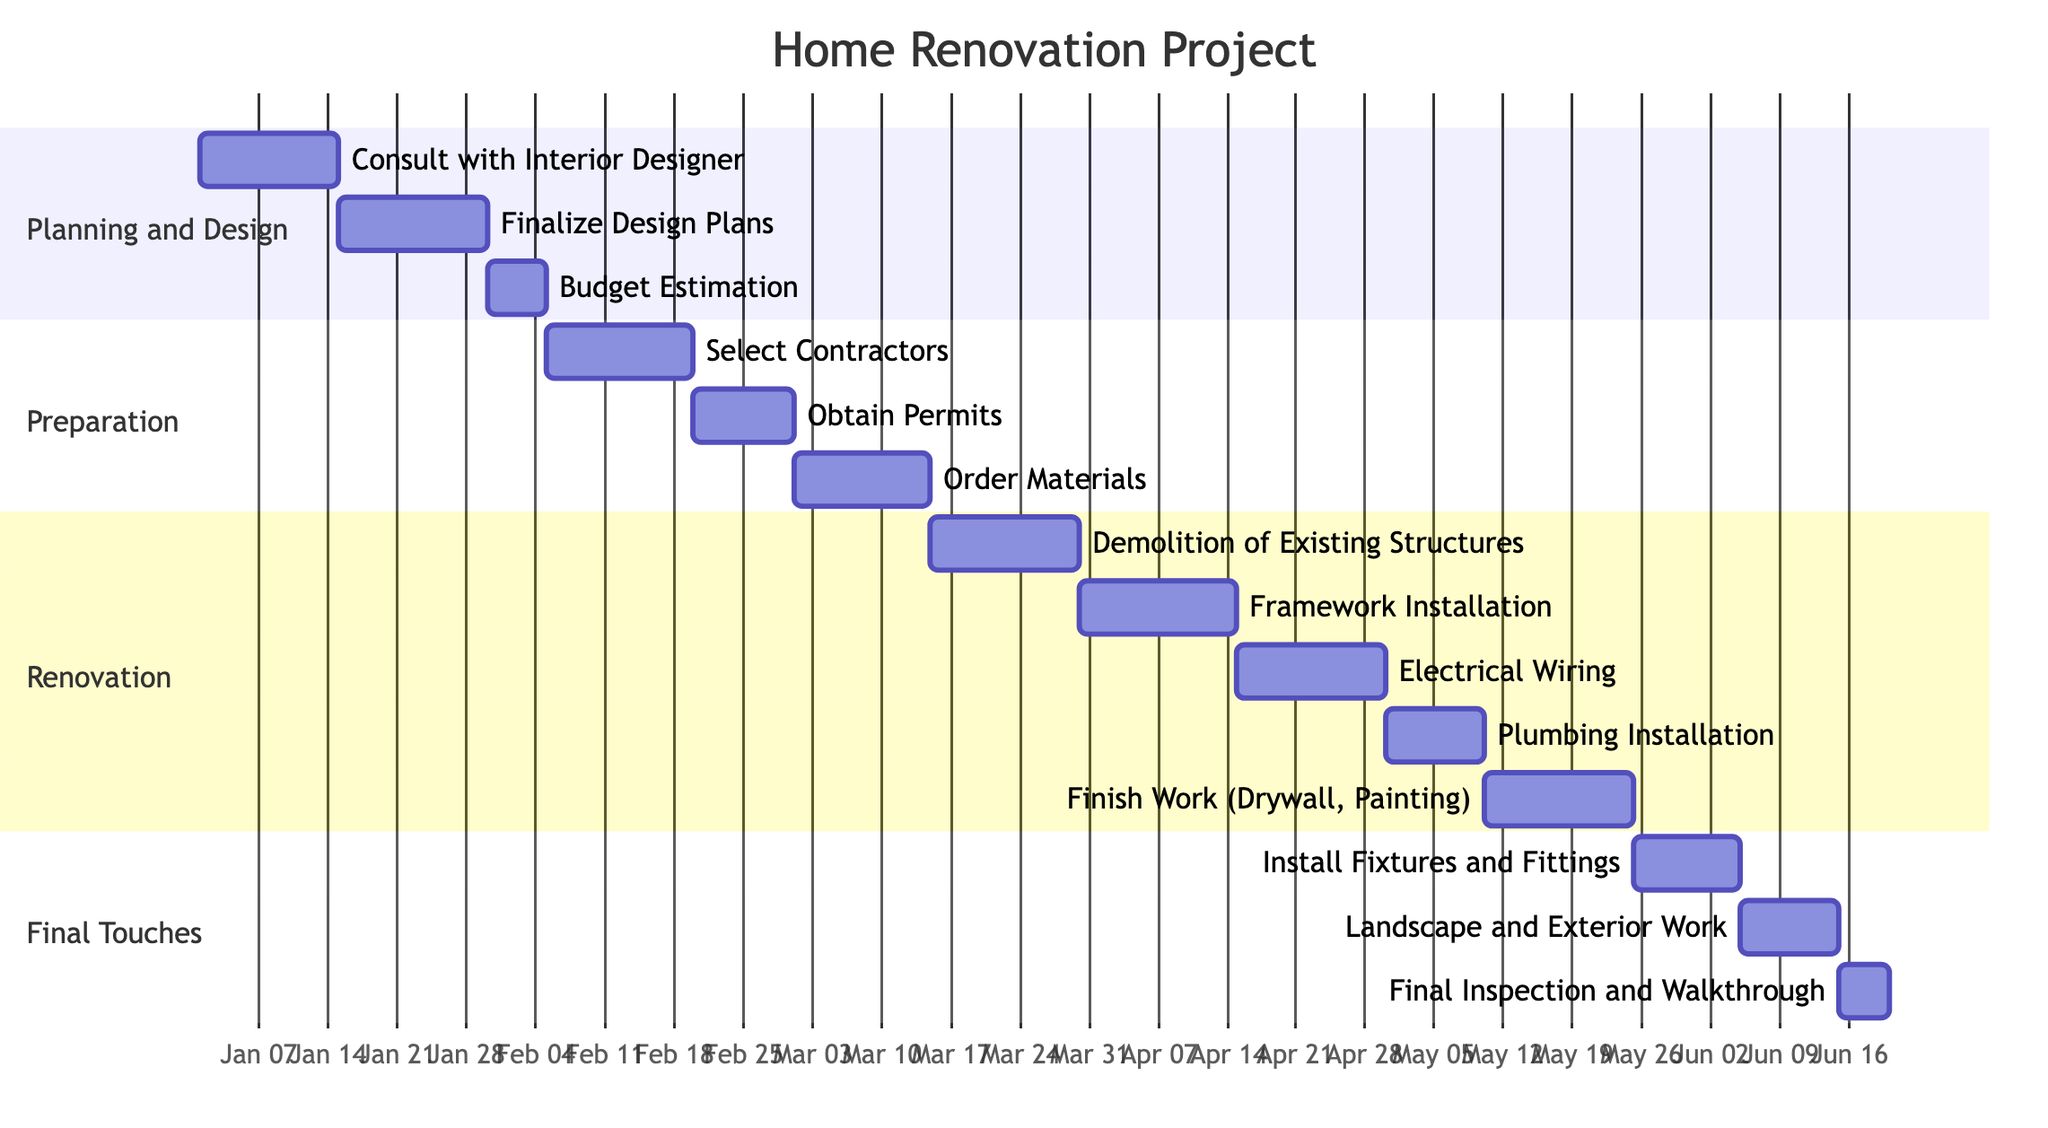What is the expected completion date for the "Budget Estimation" task? The diagram shows the task "Budget Estimation" with an expected completion date of "2024-02-05".
Answer: 2024-02-05 How many tasks are there in the "Final Touches" phase? The "Final Touches" phase has three tasks: "Install Fixtures and Fittings", "Landscape and Exterior Work", and "Final Inspection and Walkthrough".
Answer: 3 What is the task expected to be completed right after "Obtain Permits"? After "Obtain Permits", the next task is "Order Materials", as seen in the order of tasks within the "Preparation" phase.
Answer: Order Materials Which phase includes the task "Electrical Wiring"? The task "Electrical Wiring" is part of the "Renovation" phase since that is where it is located within the diagram.
Answer: Renovation How long is the "Renovation" phase expected to take in days? The "Renovation" phase begins on 2024-03-15 and ends on 2024-05-25, totaling 71 days when calculated.
Answer: 71 days Which task concludes the "Preparation" phase? The last task in the "Preparation" phase is "Order Materials", as it is the only task listed before moving to the "Renovation" phase in the diagram.
Answer: Order Materials What is the start date of the "Install Fixtures and Fittings" task? The "Install Fixtures and Fittings" task starts on "2024-05-25", as that is indicated in the timeline of the diagram.
Answer: 2024-05-25 Is there any task scheduled on March 1st? Yes, the task "Obtain Permits" is scheduled to be completed on March 1, 2024, according to the timeline shown in the diagram.
Answer: Yes 